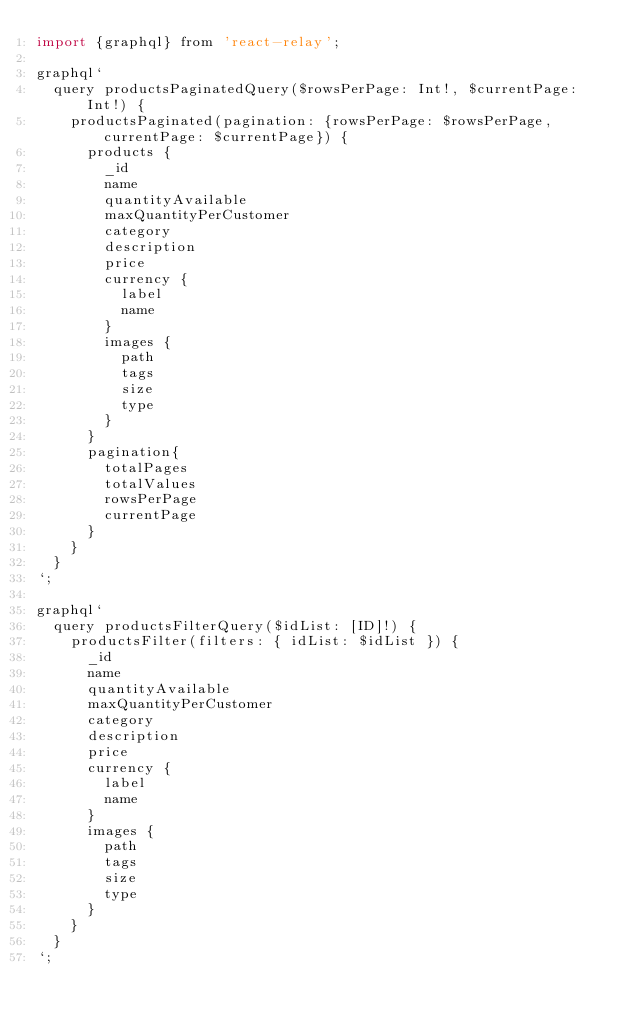<code> <loc_0><loc_0><loc_500><loc_500><_JavaScript_>import {graphql} from 'react-relay';

graphql`
  query productsPaginatedQuery($rowsPerPage: Int!, $currentPage: Int!) {
    productsPaginated(pagination: {rowsPerPage: $rowsPerPage, currentPage: $currentPage}) {
      products {
        _id
        name
        quantityAvailable
        maxQuantityPerCustomer
        category
        description
        price
        currency {
          label
          name
        }
        images {
          path
          tags
          size
          type
        }
      }
      pagination{
        totalPages
        totalValues
        rowsPerPage
        currentPage
      }
    }
  }
`;

graphql`
  query productsFilterQuery($idList: [ID]!) {
    productsFilter(filters: { idList: $idList }) {
      _id
      name
      quantityAvailable
      maxQuantityPerCustomer
      category
      description
      price
      currency {
        label
        name
      }
      images {
        path
        tags
        size
        type
      }
    }
  }
`;</code> 